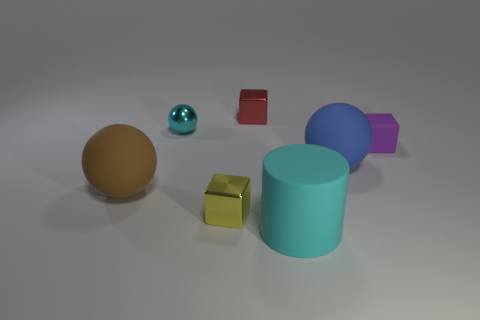Does the big rubber cylinder have the same color as the shiny sphere?
Make the answer very short. Yes. There is a tiny block that is to the right of the large cyan rubber object left of the blue object; are there any cubes in front of it?
Your answer should be very brief. Yes. How many blue rubber things have the same size as the cyan sphere?
Your answer should be very brief. 0. There is a sphere behind the blue object; is it the same size as the brown object that is in front of the big blue ball?
Provide a succinct answer. No. The object that is both in front of the large brown thing and on the left side of the cylinder has what shape?
Keep it short and to the point. Cube. Is there a rubber object of the same color as the shiny ball?
Make the answer very short. Yes. Are there any big red rubber balls?
Your answer should be compact. No. What is the color of the rubber sphere that is behind the brown matte thing?
Provide a short and direct response. Blue. There is a blue sphere; is it the same size as the shiny cube that is behind the brown rubber object?
Provide a succinct answer. No. What is the size of the thing that is behind the big blue object and on the right side of the small red metal thing?
Offer a very short reply. Small. 